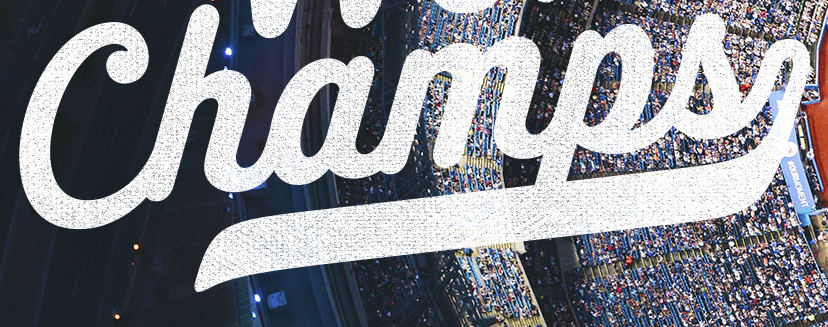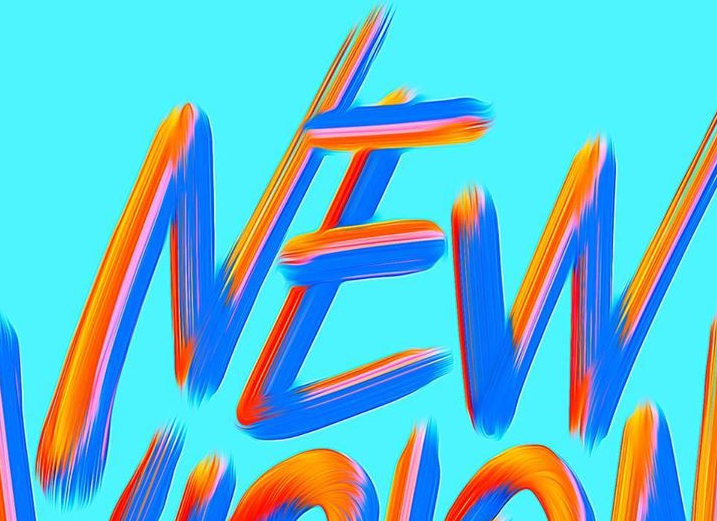What words are shown in these images in order, separated by a semicolon? Champs; NEW 